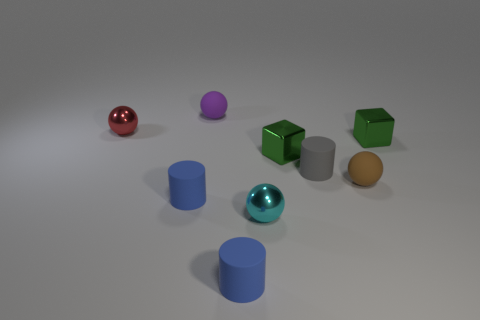What number of large objects are either blue matte cylinders or red spheres?
Provide a short and direct response. 0. There is a sphere that is both in front of the small red ball and behind the small cyan metal ball; what size is it?
Offer a very short reply. Small. There is a brown rubber sphere; what number of small blocks are behind it?
Offer a terse response. 2. There is a thing that is both left of the small purple object and behind the small gray rubber object; what is its shape?
Offer a terse response. Sphere. What number of spheres are large purple matte things or red metallic objects?
Give a very brief answer. 1. Are there fewer tiny cyan spheres that are on the left side of the small cyan shiny object than tiny red metal spheres?
Offer a very short reply. Yes. The rubber cylinder that is behind the tiny cyan shiny object and in front of the brown ball is what color?
Your response must be concise. Blue. What number of other objects are the same shape as the tiny gray object?
Make the answer very short. 2. Is the number of tiny brown balls in front of the tiny cyan sphere less than the number of cyan balls that are behind the tiny gray matte thing?
Offer a terse response. No. Are the tiny cyan sphere and the blue thing right of the small purple rubber sphere made of the same material?
Give a very brief answer. No. 